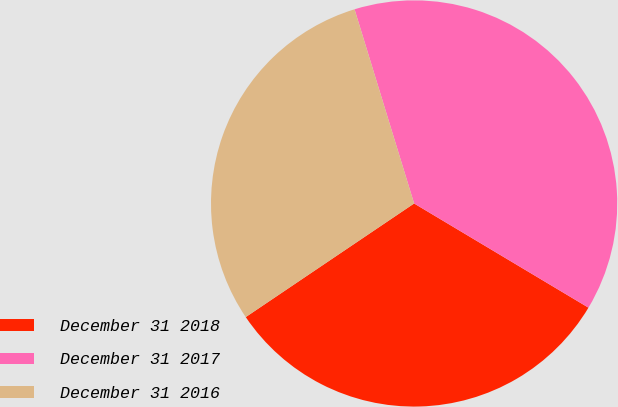Convert chart to OTSL. <chart><loc_0><loc_0><loc_500><loc_500><pie_chart><fcel>December 31 2018<fcel>December 31 2017<fcel>December 31 2016<nl><fcel>31.98%<fcel>38.31%<fcel>29.71%<nl></chart> 